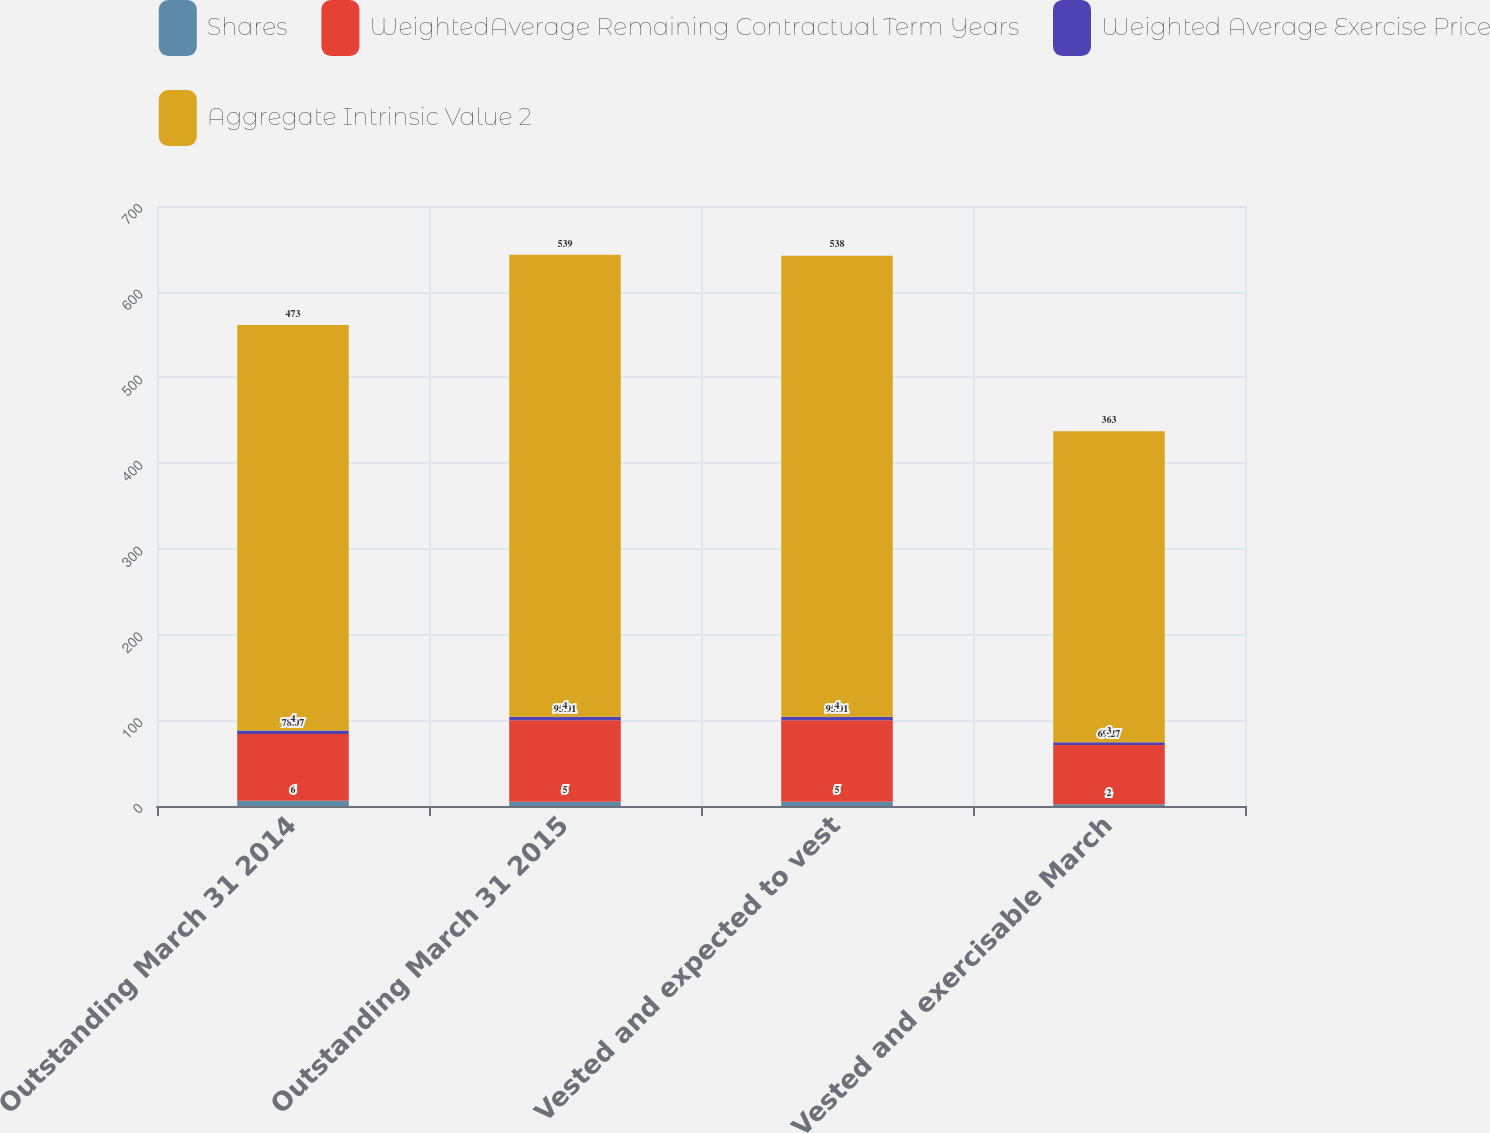Convert chart. <chart><loc_0><loc_0><loc_500><loc_500><stacked_bar_chart><ecel><fcel>Outstanding March 31 2014<fcel>Outstanding March 31 2015<fcel>Vested and expected to vest<fcel>Vested and exercisable March<nl><fcel>Shares<fcel>6<fcel>5<fcel>5<fcel>2<nl><fcel>WeightedAverage Remaining Contractual Term Years<fcel>78.07<fcel>95.01<fcel>95.01<fcel>69.27<nl><fcel>Weighted Average Exercise Price<fcel>4<fcel>4<fcel>4<fcel>3<nl><fcel>Aggregate Intrinsic Value 2<fcel>473<fcel>539<fcel>538<fcel>363<nl></chart> 